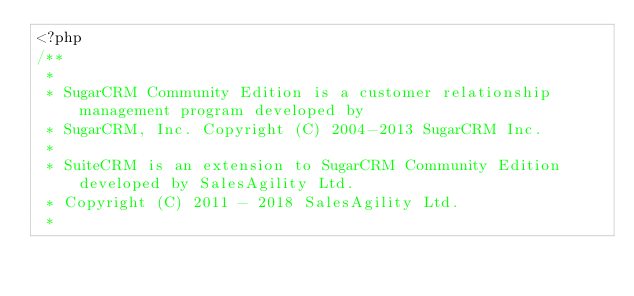Convert code to text. <code><loc_0><loc_0><loc_500><loc_500><_PHP_><?php
/**
 *
 * SugarCRM Community Edition is a customer relationship management program developed by
 * SugarCRM, Inc. Copyright (C) 2004-2013 SugarCRM Inc.
 *
 * SuiteCRM is an extension to SugarCRM Community Edition developed by SalesAgility Ltd.
 * Copyright (C) 2011 - 2018 SalesAgility Ltd.
 *</code> 